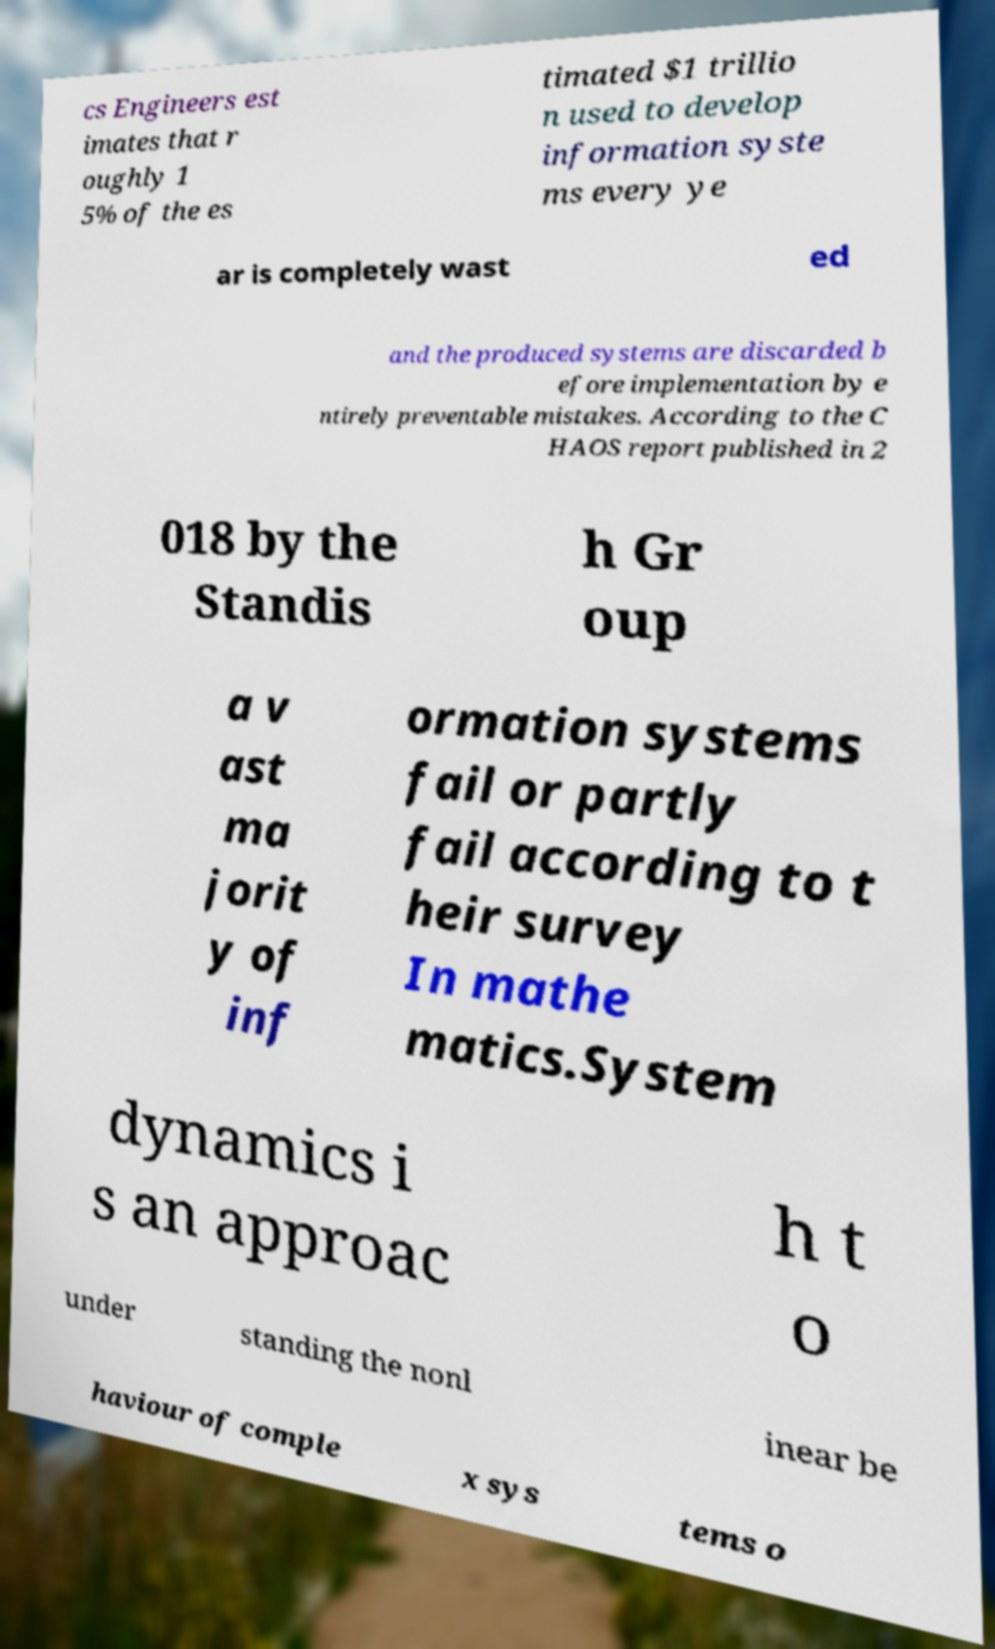Can you accurately transcribe the text from the provided image for me? cs Engineers est imates that r oughly 1 5% of the es timated $1 trillio n used to develop information syste ms every ye ar is completely wast ed and the produced systems are discarded b efore implementation by e ntirely preventable mistakes. According to the C HAOS report published in 2 018 by the Standis h Gr oup a v ast ma jorit y of inf ormation systems fail or partly fail according to t heir survey In mathe matics.System dynamics i s an approac h t o under standing the nonl inear be haviour of comple x sys tems o 